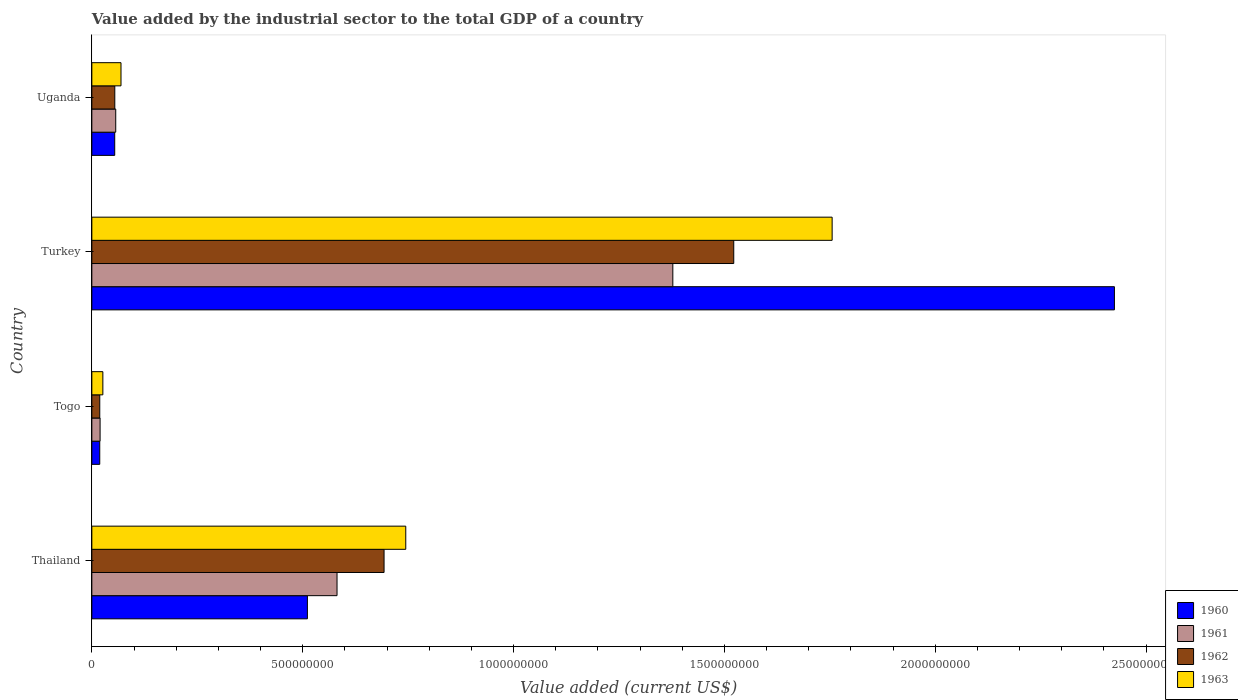How many different coloured bars are there?
Make the answer very short. 4. How many groups of bars are there?
Ensure brevity in your answer.  4. What is the label of the 3rd group of bars from the top?
Your answer should be compact. Togo. In how many cases, is the number of bars for a given country not equal to the number of legend labels?
Ensure brevity in your answer.  0. What is the value added by the industrial sector to the total GDP in 1963 in Thailand?
Make the answer very short. 7.44e+08. Across all countries, what is the maximum value added by the industrial sector to the total GDP in 1961?
Ensure brevity in your answer.  1.38e+09. Across all countries, what is the minimum value added by the industrial sector to the total GDP in 1960?
Offer a very short reply. 1.88e+07. In which country was the value added by the industrial sector to the total GDP in 1963 maximum?
Offer a very short reply. Turkey. In which country was the value added by the industrial sector to the total GDP in 1963 minimum?
Your response must be concise. Togo. What is the total value added by the industrial sector to the total GDP in 1961 in the graph?
Offer a very short reply. 2.04e+09. What is the difference between the value added by the industrial sector to the total GDP in 1963 in Togo and that in Uganda?
Provide a succinct answer. -4.30e+07. What is the difference between the value added by the industrial sector to the total GDP in 1960 in Togo and the value added by the industrial sector to the total GDP in 1963 in Thailand?
Provide a succinct answer. -7.26e+08. What is the average value added by the industrial sector to the total GDP in 1961 per country?
Give a very brief answer. 5.09e+08. What is the difference between the value added by the industrial sector to the total GDP in 1963 and value added by the industrial sector to the total GDP in 1960 in Togo?
Your response must be concise. 7.36e+06. In how many countries, is the value added by the industrial sector to the total GDP in 1963 greater than 1400000000 US$?
Give a very brief answer. 1. What is the ratio of the value added by the industrial sector to the total GDP in 1963 in Togo to that in Uganda?
Your answer should be compact. 0.38. Is the difference between the value added by the industrial sector to the total GDP in 1963 in Togo and Uganda greater than the difference between the value added by the industrial sector to the total GDP in 1960 in Togo and Uganda?
Keep it short and to the point. No. What is the difference between the highest and the second highest value added by the industrial sector to the total GDP in 1962?
Your response must be concise. 8.29e+08. What is the difference between the highest and the lowest value added by the industrial sector to the total GDP in 1960?
Your answer should be very brief. 2.41e+09. Is the sum of the value added by the industrial sector to the total GDP in 1961 in Togo and Uganda greater than the maximum value added by the industrial sector to the total GDP in 1962 across all countries?
Keep it short and to the point. No. What does the 1st bar from the bottom in Togo represents?
Your answer should be very brief. 1960. How many bars are there?
Offer a very short reply. 16. Are all the bars in the graph horizontal?
Offer a terse response. Yes. What is the difference between two consecutive major ticks on the X-axis?
Your answer should be very brief. 5.00e+08. Are the values on the major ticks of X-axis written in scientific E-notation?
Offer a very short reply. No. Where does the legend appear in the graph?
Give a very brief answer. Bottom right. How many legend labels are there?
Offer a terse response. 4. How are the legend labels stacked?
Give a very brief answer. Vertical. What is the title of the graph?
Ensure brevity in your answer.  Value added by the industrial sector to the total GDP of a country. What is the label or title of the X-axis?
Keep it short and to the point. Value added (current US$). What is the Value added (current US$) of 1960 in Thailand?
Give a very brief answer. 5.11e+08. What is the Value added (current US$) in 1961 in Thailand?
Offer a very short reply. 5.81e+08. What is the Value added (current US$) in 1962 in Thailand?
Give a very brief answer. 6.93e+08. What is the Value added (current US$) of 1963 in Thailand?
Provide a short and direct response. 7.44e+08. What is the Value added (current US$) of 1960 in Togo?
Your answer should be very brief. 1.88e+07. What is the Value added (current US$) of 1961 in Togo?
Give a very brief answer. 1.96e+07. What is the Value added (current US$) of 1962 in Togo?
Your answer should be compact. 1.88e+07. What is the Value added (current US$) in 1963 in Togo?
Your response must be concise. 2.61e+07. What is the Value added (current US$) in 1960 in Turkey?
Make the answer very short. 2.42e+09. What is the Value added (current US$) in 1961 in Turkey?
Provide a succinct answer. 1.38e+09. What is the Value added (current US$) of 1962 in Turkey?
Your answer should be compact. 1.52e+09. What is the Value added (current US$) in 1963 in Turkey?
Make the answer very short. 1.76e+09. What is the Value added (current US$) in 1960 in Uganda?
Offer a very short reply. 5.42e+07. What is the Value added (current US$) in 1961 in Uganda?
Your answer should be compact. 5.67e+07. What is the Value added (current US$) in 1962 in Uganda?
Keep it short and to the point. 5.44e+07. What is the Value added (current US$) of 1963 in Uganda?
Provide a succinct answer. 6.91e+07. Across all countries, what is the maximum Value added (current US$) in 1960?
Ensure brevity in your answer.  2.42e+09. Across all countries, what is the maximum Value added (current US$) in 1961?
Provide a succinct answer. 1.38e+09. Across all countries, what is the maximum Value added (current US$) in 1962?
Make the answer very short. 1.52e+09. Across all countries, what is the maximum Value added (current US$) in 1963?
Provide a succinct answer. 1.76e+09. Across all countries, what is the minimum Value added (current US$) of 1960?
Make the answer very short. 1.88e+07. Across all countries, what is the minimum Value added (current US$) of 1961?
Provide a succinct answer. 1.96e+07. Across all countries, what is the minimum Value added (current US$) of 1962?
Provide a short and direct response. 1.88e+07. Across all countries, what is the minimum Value added (current US$) in 1963?
Give a very brief answer. 2.61e+07. What is the total Value added (current US$) of 1960 in the graph?
Your answer should be compact. 3.01e+09. What is the total Value added (current US$) of 1961 in the graph?
Offer a terse response. 2.04e+09. What is the total Value added (current US$) in 1962 in the graph?
Your response must be concise. 2.29e+09. What is the total Value added (current US$) in 1963 in the graph?
Give a very brief answer. 2.60e+09. What is the difference between the Value added (current US$) of 1960 in Thailand and that in Togo?
Keep it short and to the point. 4.92e+08. What is the difference between the Value added (current US$) of 1961 in Thailand and that in Togo?
Make the answer very short. 5.62e+08. What is the difference between the Value added (current US$) in 1962 in Thailand and that in Togo?
Make the answer very short. 6.74e+08. What is the difference between the Value added (current US$) in 1963 in Thailand and that in Togo?
Give a very brief answer. 7.18e+08. What is the difference between the Value added (current US$) in 1960 in Thailand and that in Turkey?
Provide a succinct answer. -1.91e+09. What is the difference between the Value added (current US$) in 1961 in Thailand and that in Turkey?
Provide a short and direct response. -7.96e+08. What is the difference between the Value added (current US$) in 1962 in Thailand and that in Turkey?
Offer a terse response. -8.29e+08. What is the difference between the Value added (current US$) of 1963 in Thailand and that in Turkey?
Your response must be concise. -1.01e+09. What is the difference between the Value added (current US$) in 1960 in Thailand and that in Uganda?
Make the answer very short. 4.57e+08. What is the difference between the Value added (current US$) in 1961 in Thailand and that in Uganda?
Keep it short and to the point. 5.25e+08. What is the difference between the Value added (current US$) of 1962 in Thailand and that in Uganda?
Offer a terse response. 6.39e+08. What is the difference between the Value added (current US$) of 1963 in Thailand and that in Uganda?
Give a very brief answer. 6.75e+08. What is the difference between the Value added (current US$) in 1960 in Togo and that in Turkey?
Make the answer very short. -2.41e+09. What is the difference between the Value added (current US$) in 1961 in Togo and that in Turkey?
Ensure brevity in your answer.  -1.36e+09. What is the difference between the Value added (current US$) of 1962 in Togo and that in Turkey?
Your answer should be compact. -1.50e+09. What is the difference between the Value added (current US$) in 1963 in Togo and that in Turkey?
Offer a terse response. -1.73e+09. What is the difference between the Value added (current US$) of 1960 in Togo and that in Uganda?
Offer a very short reply. -3.55e+07. What is the difference between the Value added (current US$) of 1961 in Togo and that in Uganda?
Make the answer very short. -3.71e+07. What is the difference between the Value added (current US$) in 1962 in Togo and that in Uganda?
Offer a terse response. -3.56e+07. What is the difference between the Value added (current US$) of 1963 in Togo and that in Uganda?
Provide a short and direct response. -4.30e+07. What is the difference between the Value added (current US$) of 1960 in Turkey and that in Uganda?
Your response must be concise. 2.37e+09. What is the difference between the Value added (current US$) in 1961 in Turkey and that in Uganda?
Your response must be concise. 1.32e+09. What is the difference between the Value added (current US$) in 1962 in Turkey and that in Uganda?
Make the answer very short. 1.47e+09. What is the difference between the Value added (current US$) of 1963 in Turkey and that in Uganda?
Give a very brief answer. 1.69e+09. What is the difference between the Value added (current US$) of 1960 in Thailand and the Value added (current US$) of 1961 in Togo?
Your answer should be compact. 4.92e+08. What is the difference between the Value added (current US$) of 1960 in Thailand and the Value added (current US$) of 1962 in Togo?
Offer a very short reply. 4.92e+08. What is the difference between the Value added (current US$) in 1960 in Thailand and the Value added (current US$) in 1963 in Togo?
Your response must be concise. 4.85e+08. What is the difference between the Value added (current US$) in 1961 in Thailand and the Value added (current US$) in 1962 in Togo?
Offer a terse response. 5.63e+08. What is the difference between the Value added (current US$) of 1961 in Thailand and the Value added (current US$) of 1963 in Togo?
Keep it short and to the point. 5.55e+08. What is the difference between the Value added (current US$) of 1962 in Thailand and the Value added (current US$) of 1963 in Togo?
Offer a terse response. 6.67e+08. What is the difference between the Value added (current US$) in 1960 in Thailand and the Value added (current US$) in 1961 in Turkey?
Make the answer very short. -8.67e+08. What is the difference between the Value added (current US$) of 1960 in Thailand and the Value added (current US$) of 1962 in Turkey?
Your answer should be compact. -1.01e+09. What is the difference between the Value added (current US$) in 1960 in Thailand and the Value added (current US$) in 1963 in Turkey?
Your response must be concise. -1.24e+09. What is the difference between the Value added (current US$) of 1961 in Thailand and the Value added (current US$) of 1962 in Turkey?
Your answer should be compact. -9.41e+08. What is the difference between the Value added (current US$) in 1961 in Thailand and the Value added (current US$) in 1963 in Turkey?
Provide a short and direct response. -1.17e+09. What is the difference between the Value added (current US$) of 1962 in Thailand and the Value added (current US$) of 1963 in Turkey?
Offer a terse response. -1.06e+09. What is the difference between the Value added (current US$) in 1960 in Thailand and the Value added (current US$) in 1961 in Uganda?
Offer a terse response. 4.55e+08. What is the difference between the Value added (current US$) of 1960 in Thailand and the Value added (current US$) of 1962 in Uganda?
Make the answer very short. 4.57e+08. What is the difference between the Value added (current US$) of 1960 in Thailand and the Value added (current US$) of 1963 in Uganda?
Offer a very short reply. 4.42e+08. What is the difference between the Value added (current US$) in 1961 in Thailand and the Value added (current US$) in 1962 in Uganda?
Provide a short and direct response. 5.27e+08. What is the difference between the Value added (current US$) in 1961 in Thailand and the Value added (current US$) in 1963 in Uganda?
Offer a terse response. 5.12e+08. What is the difference between the Value added (current US$) in 1962 in Thailand and the Value added (current US$) in 1963 in Uganda?
Provide a succinct answer. 6.24e+08. What is the difference between the Value added (current US$) in 1960 in Togo and the Value added (current US$) in 1961 in Turkey?
Offer a terse response. -1.36e+09. What is the difference between the Value added (current US$) in 1960 in Togo and the Value added (current US$) in 1962 in Turkey?
Give a very brief answer. -1.50e+09. What is the difference between the Value added (current US$) in 1960 in Togo and the Value added (current US$) in 1963 in Turkey?
Ensure brevity in your answer.  -1.74e+09. What is the difference between the Value added (current US$) of 1961 in Togo and the Value added (current US$) of 1962 in Turkey?
Keep it short and to the point. -1.50e+09. What is the difference between the Value added (current US$) in 1961 in Togo and the Value added (current US$) in 1963 in Turkey?
Offer a terse response. -1.74e+09. What is the difference between the Value added (current US$) in 1962 in Togo and the Value added (current US$) in 1963 in Turkey?
Provide a short and direct response. -1.74e+09. What is the difference between the Value added (current US$) of 1960 in Togo and the Value added (current US$) of 1961 in Uganda?
Ensure brevity in your answer.  -3.79e+07. What is the difference between the Value added (current US$) of 1960 in Togo and the Value added (current US$) of 1962 in Uganda?
Your answer should be compact. -3.57e+07. What is the difference between the Value added (current US$) of 1960 in Togo and the Value added (current US$) of 1963 in Uganda?
Offer a terse response. -5.04e+07. What is the difference between the Value added (current US$) of 1961 in Togo and the Value added (current US$) of 1962 in Uganda?
Your answer should be compact. -3.49e+07. What is the difference between the Value added (current US$) in 1961 in Togo and the Value added (current US$) in 1963 in Uganda?
Make the answer very short. -4.96e+07. What is the difference between the Value added (current US$) in 1962 in Togo and the Value added (current US$) in 1963 in Uganda?
Your answer should be compact. -5.04e+07. What is the difference between the Value added (current US$) in 1960 in Turkey and the Value added (current US$) in 1961 in Uganda?
Your answer should be compact. 2.37e+09. What is the difference between the Value added (current US$) of 1960 in Turkey and the Value added (current US$) of 1962 in Uganda?
Offer a terse response. 2.37e+09. What is the difference between the Value added (current US$) in 1960 in Turkey and the Value added (current US$) in 1963 in Uganda?
Keep it short and to the point. 2.36e+09. What is the difference between the Value added (current US$) of 1961 in Turkey and the Value added (current US$) of 1962 in Uganda?
Offer a very short reply. 1.32e+09. What is the difference between the Value added (current US$) in 1961 in Turkey and the Value added (current US$) in 1963 in Uganda?
Provide a short and direct response. 1.31e+09. What is the difference between the Value added (current US$) of 1962 in Turkey and the Value added (current US$) of 1963 in Uganda?
Provide a short and direct response. 1.45e+09. What is the average Value added (current US$) in 1960 per country?
Provide a succinct answer. 7.52e+08. What is the average Value added (current US$) in 1961 per country?
Keep it short and to the point. 5.09e+08. What is the average Value added (current US$) of 1962 per country?
Offer a terse response. 5.72e+08. What is the average Value added (current US$) in 1963 per country?
Keep it short and to the point. 6.49e+08. What is the difference between the Value added (current US$) in 1960 and Value added (current US$) in 1961 in Thailand?
Your answer should be very brief. -7.03e+07. What is the difference between the Value added (current US$) in 1960 and Value added (current US$) in 1962 in Thailand?
Keep it short and to the point. -1.82e+08. What is the difference between the Value added (current US$) of 1960 and Value added (current US$) of 1963 in Thailand?
Give a very brief answer. -2.33e+08. What is the difference between the Value added (current US$) in 1961 and Value added (current US$) in 1962 in Thailand?
Provide a short and direct response. -1.12e+08. What is the difference between the Value added (current US$) of 1961 and Value added (current US$) of 1963 in Thailand?
Keep it short and to the point. -1.63e+08. What is the difference between the Value added (current US$) in 1962 and Value added (current US$) in 1963 in Thailand?
Keep it short and to the point. -5.15e+07. What is the difference between the Value added (current US$) in 1960 and Value added (current US$) in 1961 in Togo?
Your answer should be compact. -8.10e+05. What is the difference between the Value added (current US$) in 1960 and Value added (current US$) in 1962 in Togo?
Your answer should be compact. -1.39e+04. What is the difference between the Value added (current US$) in 1960 and Value added (current US$) in 1963 in Togo?
Offer a very short reply. -7.36e+06. What is the difference between the Value added (current US$) in 1961 and Value added (current US$) in 1962 in Togo?
Make the answer very short. 7.97e+05. What is the difference between the Value added (current US$) of 1961 and Value added (current US$) of 1963 in Togo?
Give a very brief answer. -6.55e+06. What is the difference between the Value added (current US$) of 1962 and Value added (current US$) of 1963 in Togo?
Your answer should be compact. -7.35e+06. What is the difference between the Value added (current US$) in 1960 and Value added (current US$) in 1961 in Turkey?
Make the answer very short. 1.05e+09. What is the difference between the Value added (current US$) of 1960 and Value added (current US$) of 1962 in Turkey?
Offer a very short reply. 9.03e+08. What is the difference between the Value added (current US$) of 1960 and Value added (current US$) of 1963 in Turkey?
Your response must be concise. 6.69e+08. What is the difference between the Value added (current US$) of 1961 and Value added (current US$) of 1962 in Turkey?
Your answer should be compact. -1.44e+08. What is the difference between the Value added (current US$) of 1961 and Value added (current US$) of 1963 in Turkey?
Provide a short and direct response. -3.78e+08. What is the difference between the Value added (current US$) in 1962 and Value added (current US$) in 1963 in Turkey?
Give a very brief answer. -2.33e+08. What is the difference between the Value added (current US$) in 1960 and Value added (current US$) in 1961 in Uganda?
Give a very brief answer. -2.43e+06. What is the difference between the Value added (current US$) of 1960 and Value added (current US$) of 1962 in Uganda?
Make the answer very short. -1.93e+05. What is the difference between the Value added (current US$) in 1960 and Value added (current US$) in 1963 in Uganda?
Your response must be concise. -1.49e+07. What is the difference between the Value added (current US$) of 1961 and Value added (current US$) of 1962 in Uganda?
Keep it short and to the point. 2.24e+06. What is the difference between the Value added (current US$) of 1961 and Value added (current US$) of 1963 in Uganda?
Offer a terse response. -1.25e+07. What is the difference between the Value added (current US$) of 1962 and Value added (current US$) of 1963 in Uganda?
Your answer should be very brief. -1.47e+07. What is the ratio of the Value added (current US$) in 1960 in Thailand to that in Togo?
Provide a succinct answer. 27.25. What is the ratio of the Value added (current US$) in 1961 in Thailand to that in Togo?
Offer a terse response. 29.71. What is the ratio of the Value added (current US$) in 1962 in Thailand to that in Togo?
Offer a very short reply. 36.91. What is the ratio of the Value added (current US$) in 1963 in Thailand to that in Togo?
Offer a very short reply. 28.5. What is the ratio of the Value added (current US$) in 1960 in Thailand to that in Turkey?
Offer a terse response. 0.21. What is the ratio of the Value added (current US$) in 1961 in Thailand to that in Turkey?
Keep it short and to the point. 0.42. What is the ratio of the Value added (current US$) of 1962 in Thailand to that in Turkey?
Keep it short and to the point. 0.46. What is the ratio of the Value added (current US$) of 1963 in Thailand to that in Turkey?
Ensure brevity in your answer.  0.42. What is the ratio of the Value added (current US$) in 1960 in Thailand to that in Uganda?
Give a very brief answer. 9.43. What is the ratio of the Value added (current US$) in 1961 in Thailand to that in Uganda?
Keep it short and to the point. 10.26. What is the ratio of the Value added (current US$) in 1962 in Thailand to that in Uganda?
Your answer should be very brief. 12.73. What is the ratio of the Value added (current US$) of 1963 in Thailand to that in Uganda?
Your response must be concise. 10.77. What is the ratio of the Value added (current US$) in 1960 in Togo to that in Turkey?
Make the answer very short. 0.01. What is the ratio of the Value added (current US$) of 1961 in Togo to that in Turkey?
Make the answer very short. 0.01. What is the ratio of the Value added (current US$) in 1962 in Togo to that in Turkey?
Keep it short and to the point. 0.01. What is the ratio of the Value added (current US$) in 1963 in Togo to that in Turkey?
Give a very brief answer. 0.01. What is the ratio of the Value added (current US$) of 1960 in Togo to that in Uganda?
Your response must be concise. 0.35. What is the ratio of the Value added (current US$) of 1961 in Togo to that in Uganda?
Your answer should be compact. 0.35. What is the ratio of the Value added (current US$) of 1962 in Togo to that in Uganda?
Provide a succinct answer. 0.34. What is the ratio of the Value added (current US$) in 1963 in Togo to that in Uganda?
Provide a short and direct response. 0.38. What is the ratio of the Value added (current US$) of 1960 in Turkey to that in Uganda?
Make the answer very short. 44.72. What is the ratio of the Value added (current US$) in 1961 in Turkey to that in Uganda?
Give a very brief answer. 24.32. What is the ratio of the Value added (current US$) in 1962 in Turkey to that in Uganda?
Ensure brevity in your answer.  27.97. What is the ratio of the Value added (current US$) in 1963 in Turkey to that in Uganda?
Provide a succinct answer. 25.39. What is the difference between the highest and the second highest Value added (current US$) in 1960?
Your answer should be very brief. 1.91e+09. What is the difference between the highest and the second highest Value added (current US$) in 1961?
Provide a short and direct response. 7.96e+08. What is the difference between the highest and the second highest Value added (current US$) in 1962?
Give a very brief answer. 8.29e+08. What is the difference between the highest and the second highest Value added (current US$) of 1963?
Your answer should be compact. 1.01e+09. What is the difference between the highest and the lowest Value added (current US$) of 1960?
Offer a terse response. 2.41e+09. What is the difference between the highest and the lowest Value added (current US$) in 1961?
Offer a terse response. 1.36e+09. What is the difference between the highest and the lowest Value added (current US$) in 1962?
Keep it short and to the point. 1.50e+09. What is the difference between the highest and the lowest Value added (current US$) of 1963?
Your answer should be very brief. 1.73e+09. 